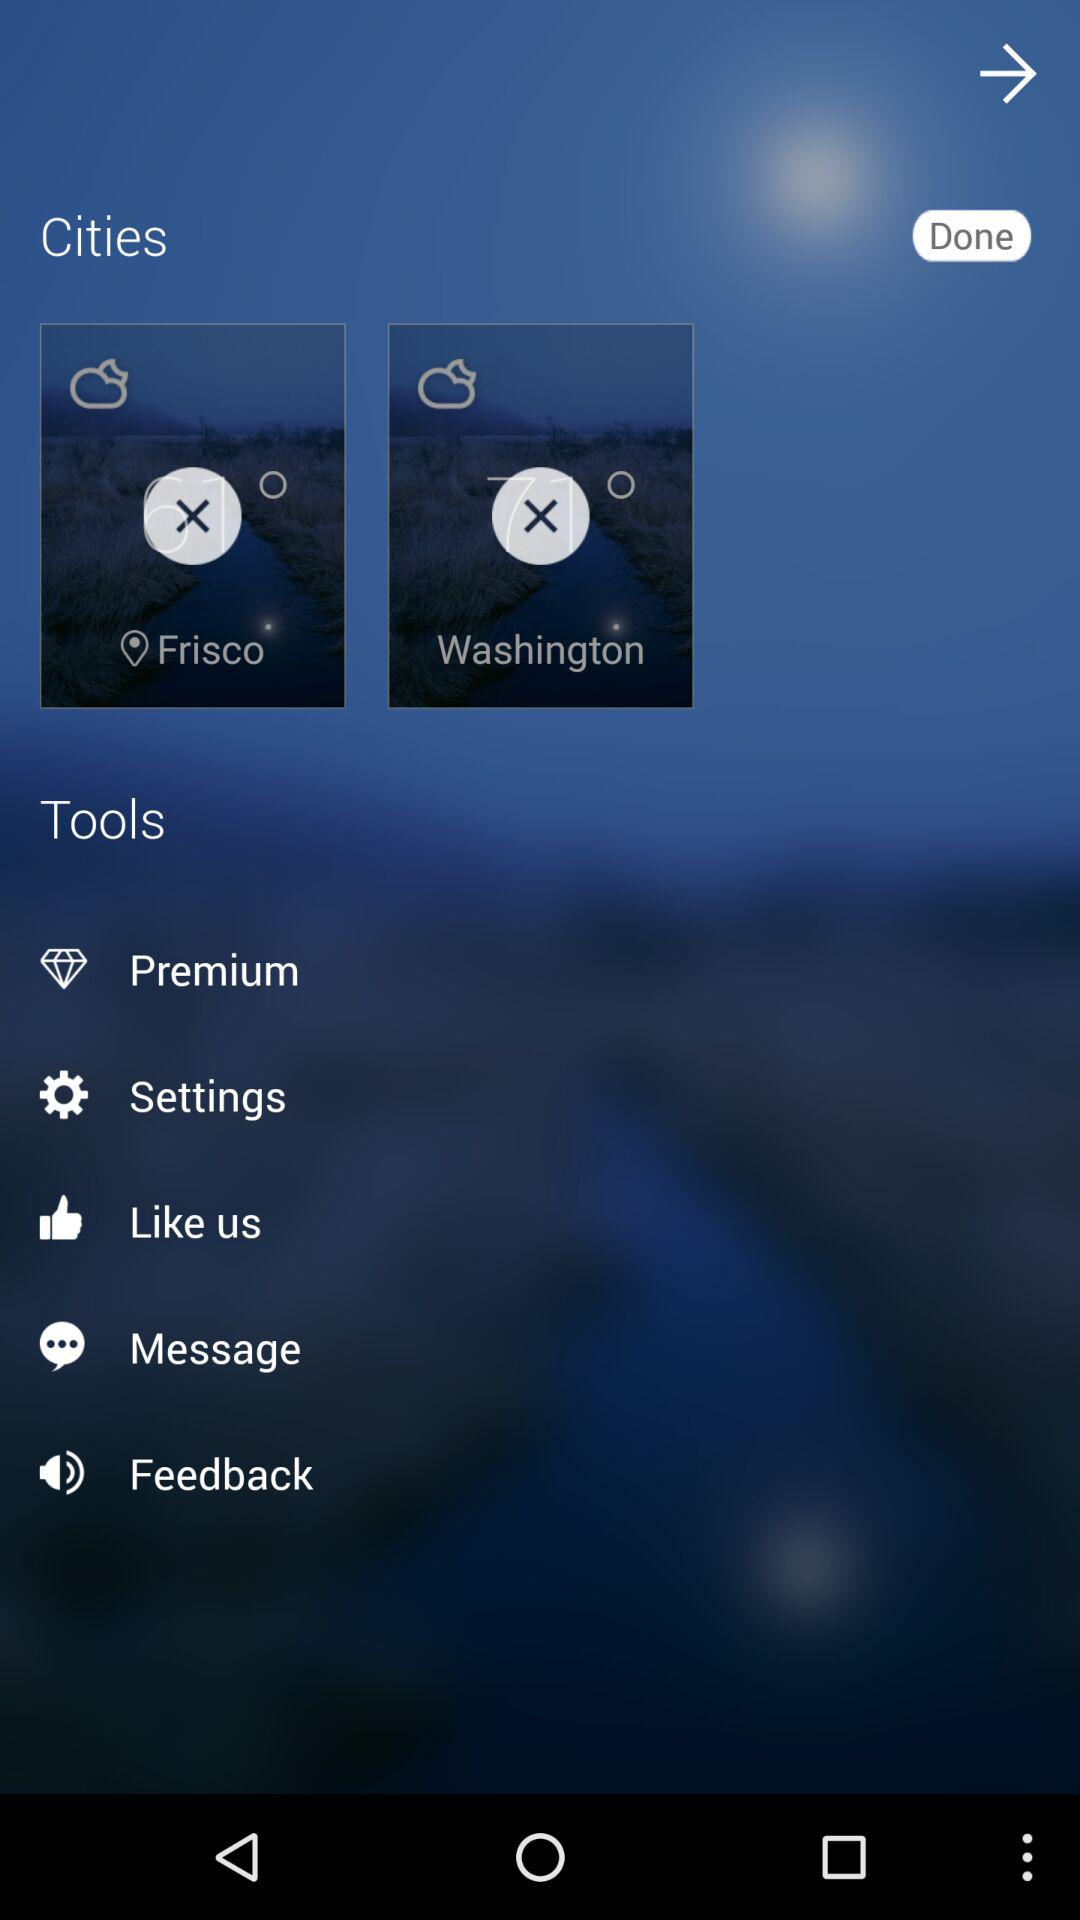What are the selected cities? The selected cities are "Frisco" and "Washington". 